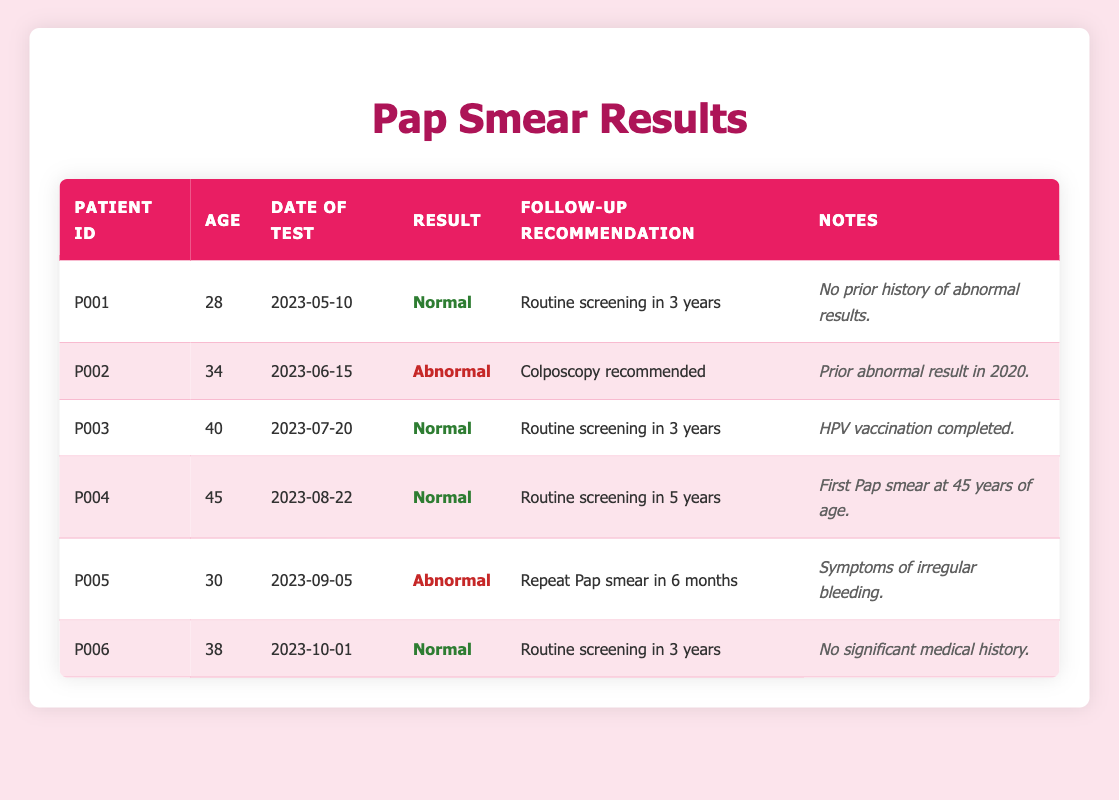What is the follow-up recommendation for Patient ID P002? From the table, under the "Follow-Up Recommendation" column for Patient ID P002, the recommendation is "Colposcopy recommended."
Answer: Colposcopy recommended How many patients had a normal Pap smear result? By reviewing the "Result" column, there are three entries where the result is "Normal" (Patient IDs P001, P003, and P004).
Answer: 3 What is the age of the patient who had their first Pap smear? Looking at the notes in the table, Patient ID P004 has the note "First Pap smear at 45 years of age." Therefore, the age of this patient is 45.
Answer: 45 Which patient had symptoms of irregular bleeding? In the "Notes" column, Patient ID P005 is noted to have "Symptoms of irregular bleeding," indicating that this patient experienced such symptoms.
Answer: P005 What is the average age of patients with abnormal results? The patients with abnormal results are P002 (34 years) and P005 (30 years). Adding these ages together gives 64, and dividing by the number of patients (2) results in an average age of 32.
Answer: 32 Did any patients have a Pap smear result that required screening in less than 3 years? By examining the "Follow-Up Recommendation" column, Patient ID P005 requires a repeat Pap smear in 6 months, which is less than 3 years. Therefore, the answer is yes.
Answer: Yes What is the difference in age between the youngest and oldest patients? The youngest patient is P005 at 30 years, and the oldest is P004 at 45 years. The difference in age is 45 - 30 = 15 years.
Answer: 15 How many patients need routine screening in 3 years according to their results? Reviewing the "Follow-Up Recommendation" column, the patients who need routine screening in 3 years include P001, P003, and P006. This totals three patients.
Answer: 3 What was the most recent date of the Pap smear tests conducted? The dates of tests in the "Date of Test" column list the most recent date as 2023-10-01 for Patient ID P006.
Answer: 2023-10-01 